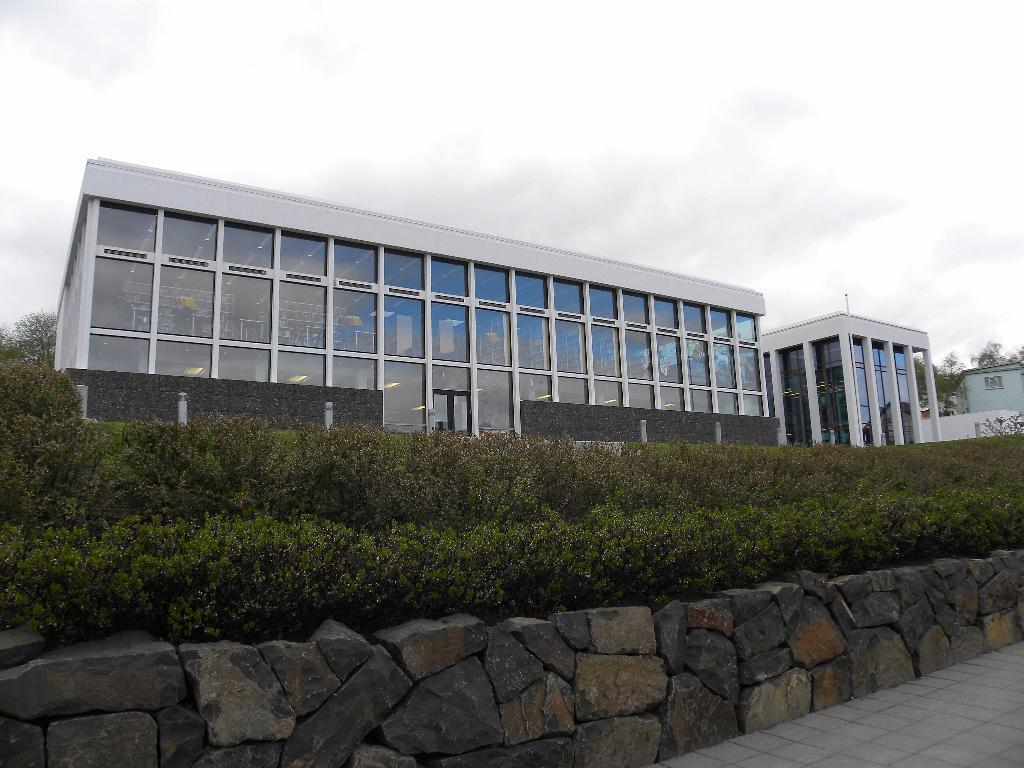What type of structures can be seen in the image? There are buildings in the image. What other natural elements are present in the image? There are plants and trees in the image. What type of barrier can be seen in the image? There is a rock wall in the image. What is visible in the background of the image? The sky is visible in the background of the image. How many chairs are placed on the rock wall in the image? There are no chairs present on the rock wall in the image. What type of animal can be seen performing a show in the image? There is no animal performing a show in the image; it features buildings, plants, trees, a rock wall, and the sky. 